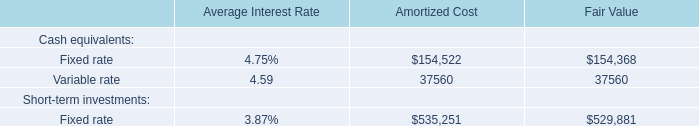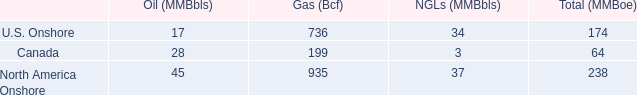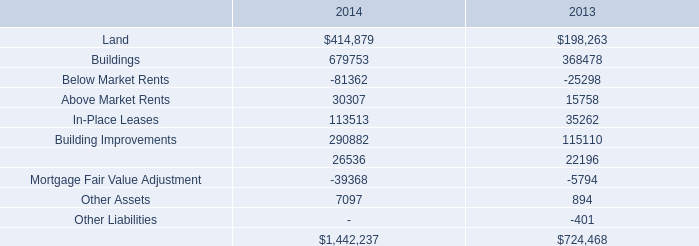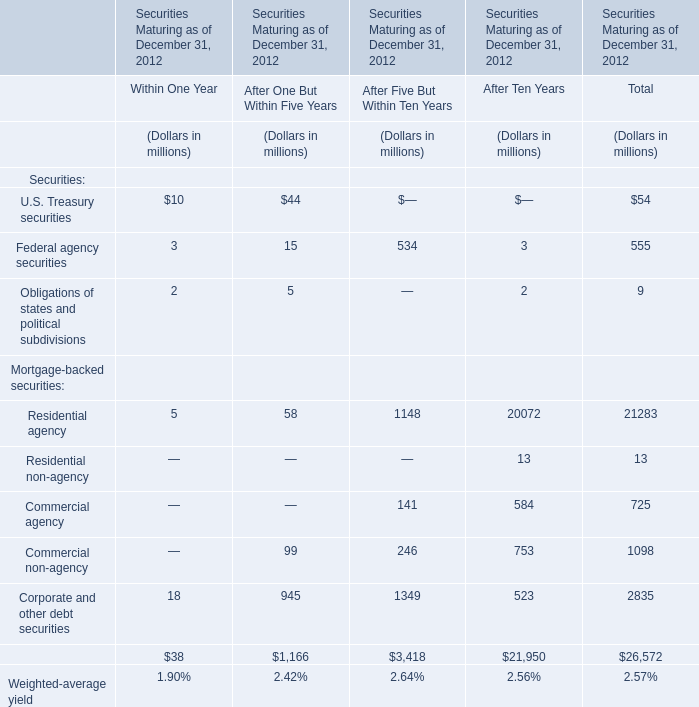what percentage of north america gas comes from us onshore? 
Computations: ((736 / 935) * 100)
Answer: 78.71658. 